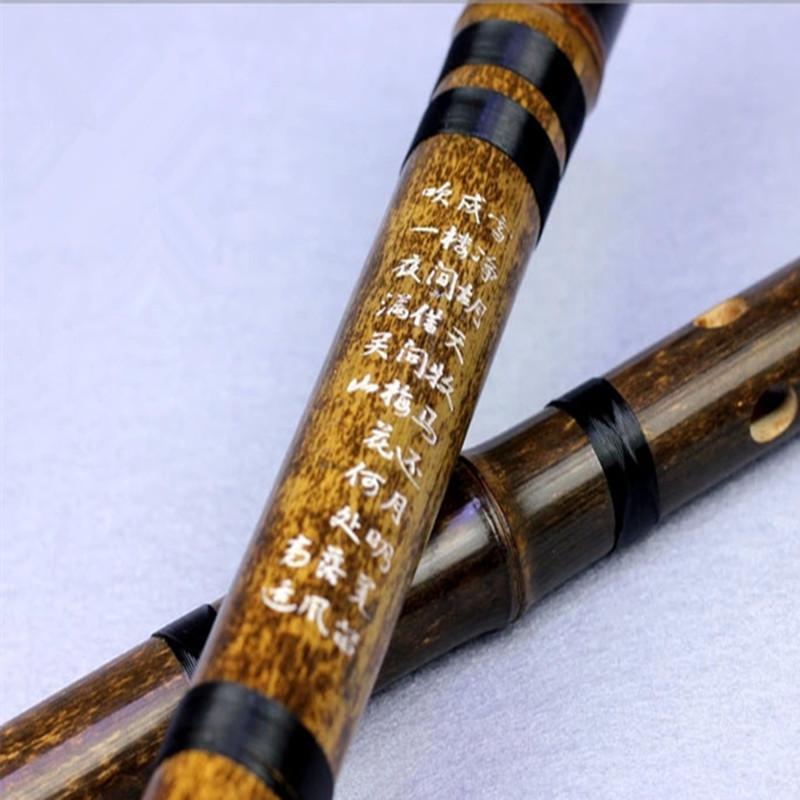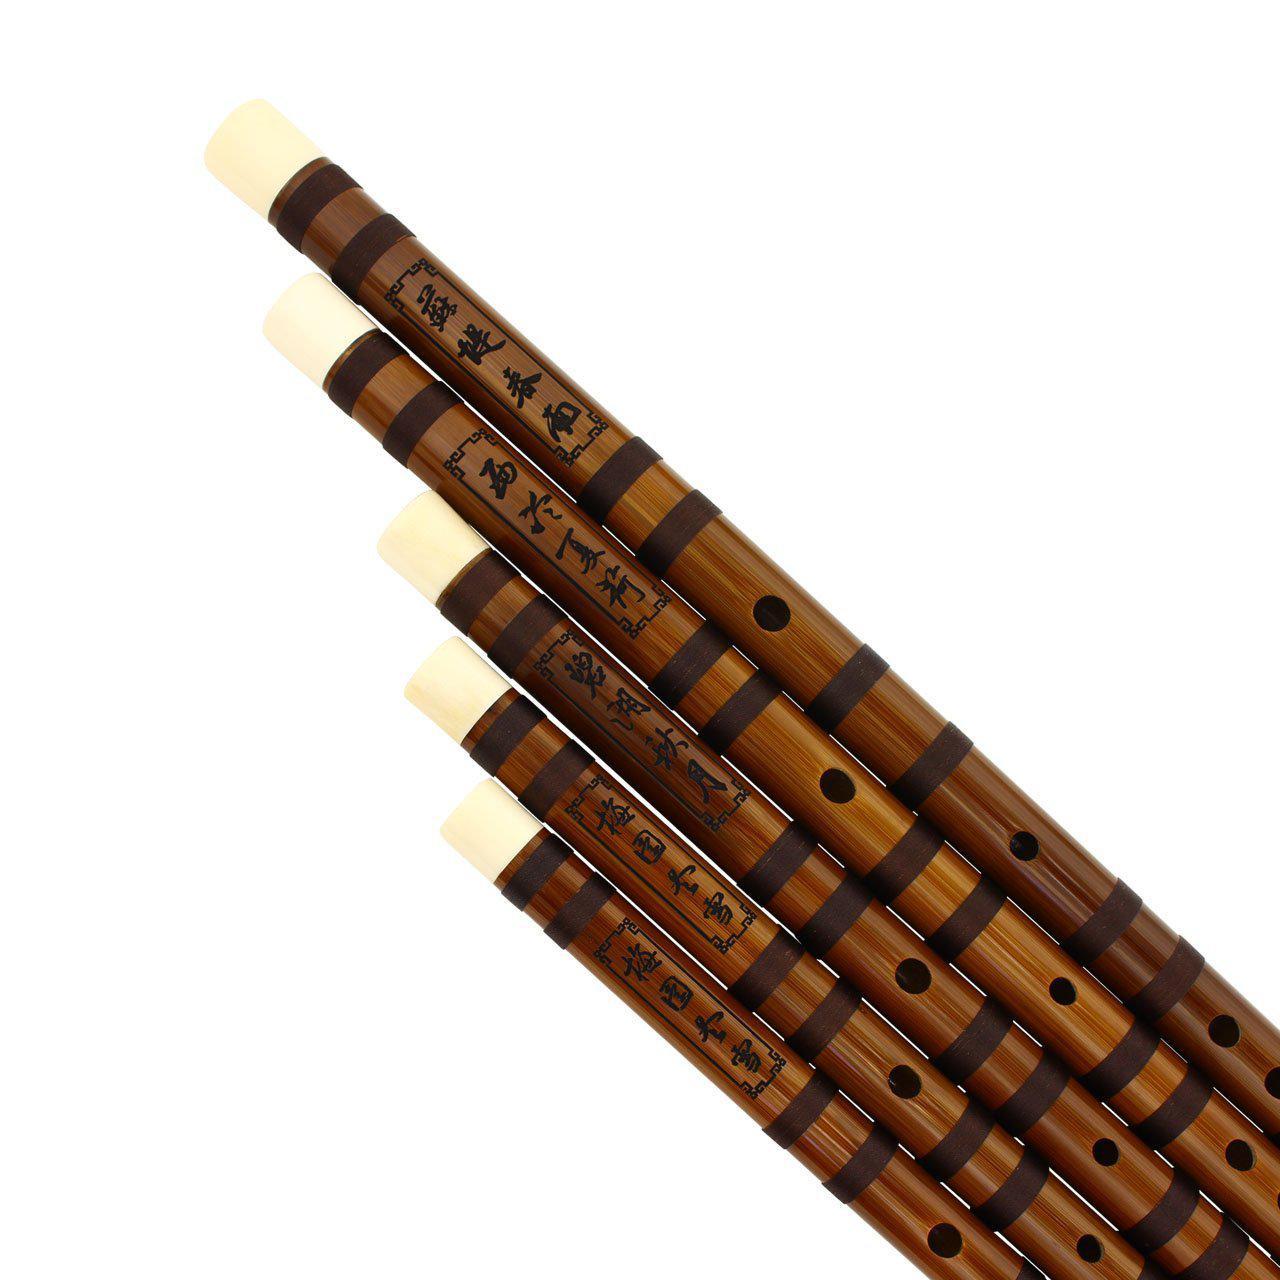The first image is the image on the left, the second image is the image on the right. Evaluate the accuracy of this statement regarding the images: "One image shows two diagonally displayed, side-by-side wooden flutes, and the other image shows at least one hole in a single wooden flute.". Is it true? Answer yes or no. No. The first image is the image on the left, the second image is the image on the right. For the images shown, is this caption "There are two flutes in the left image." true? Answer yes or no. Yes. 